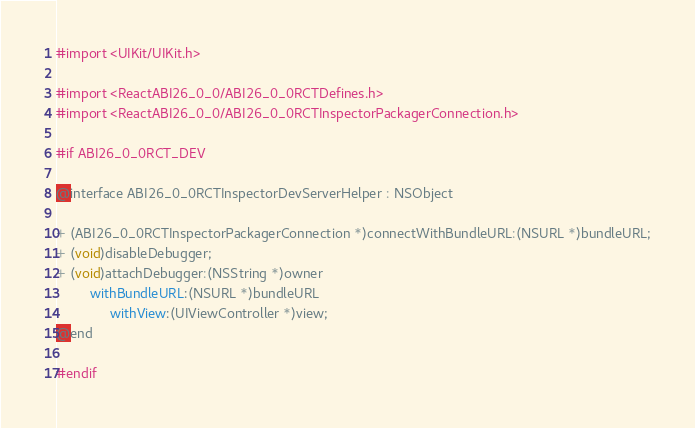Convert code to text. <code><loc_0><loc_0><loc_500><loc_500><_C_>#import <UIKit/UIKit.h>

#import <ReactABI26_0_0/ABI26_0_0RCTDefines.h>
#import <ReactABI26_0_0/ABI26_0_0RCTInspectorPackagerConnection.h>

#if ABI26_0_0RCT_DEV

@interface ABI26_0_0RCTInspectorDevServerHelper : NSObject

+ (ABI26_0_0RCTInspectorPackagerConnection *)connectWithBundleURL:(NSURL *)bundleURL;
+ (void)disableDebugger;
+ (void)attachDebugger:(NSString *)owner
         withBundleURL:(NSURL *)bundleURL
              withView:(UIViewController *)view;
@end

#endif
</code> 